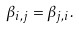Convert formula to latex. <formula><loc_0><loc_0><loc_500><loc_500>\beta _ { i , j } = \beta _ { j , i } .</formula> 